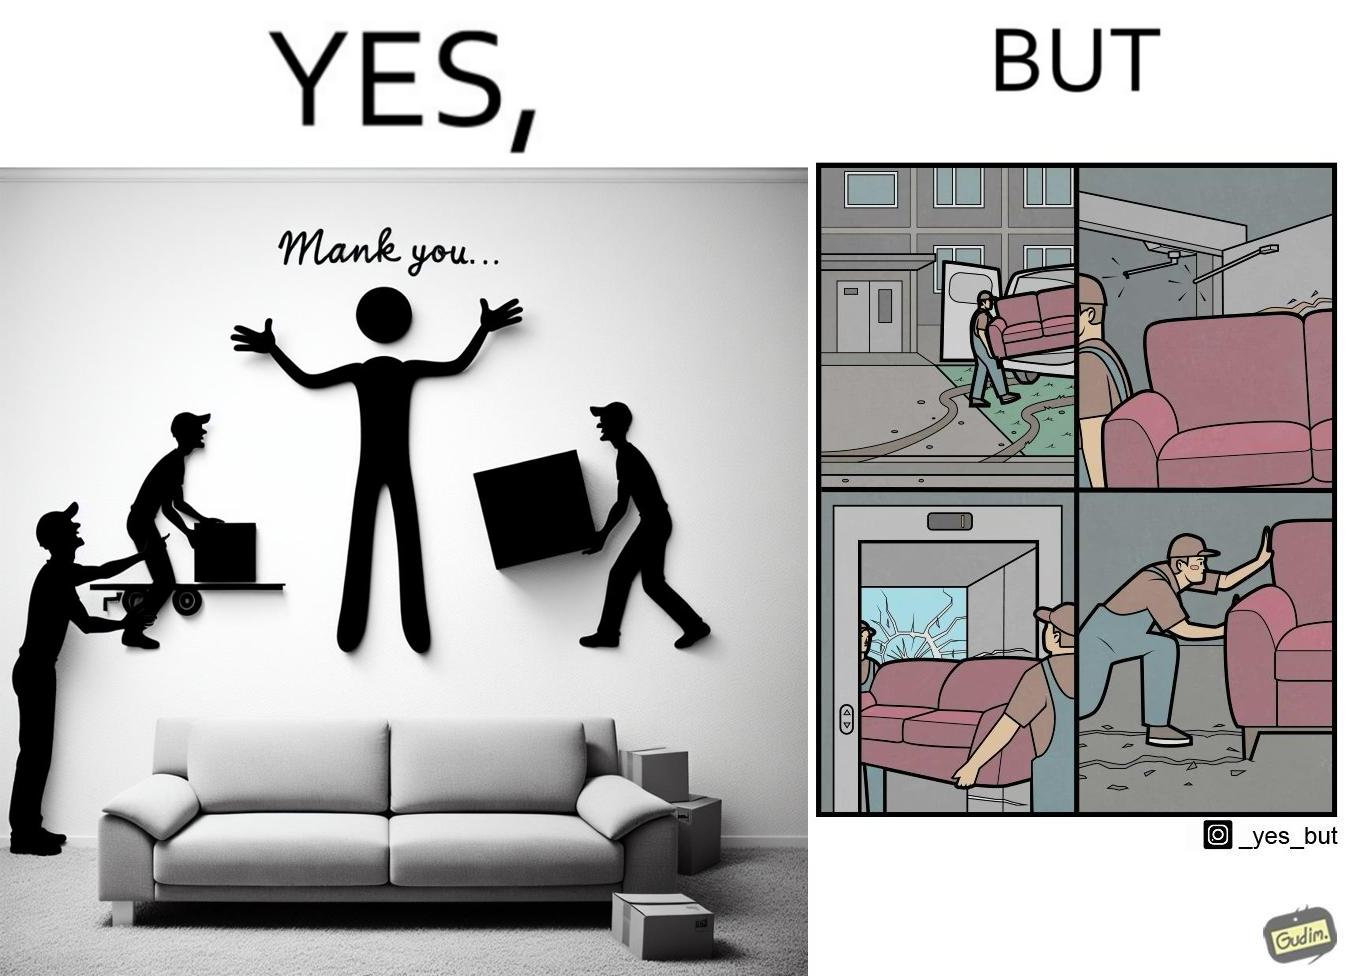Describe the content of this image. The images are funny since they show how even though the hired movers achieve their task of moving in furniture, in the process, the cause damage to the whole house 